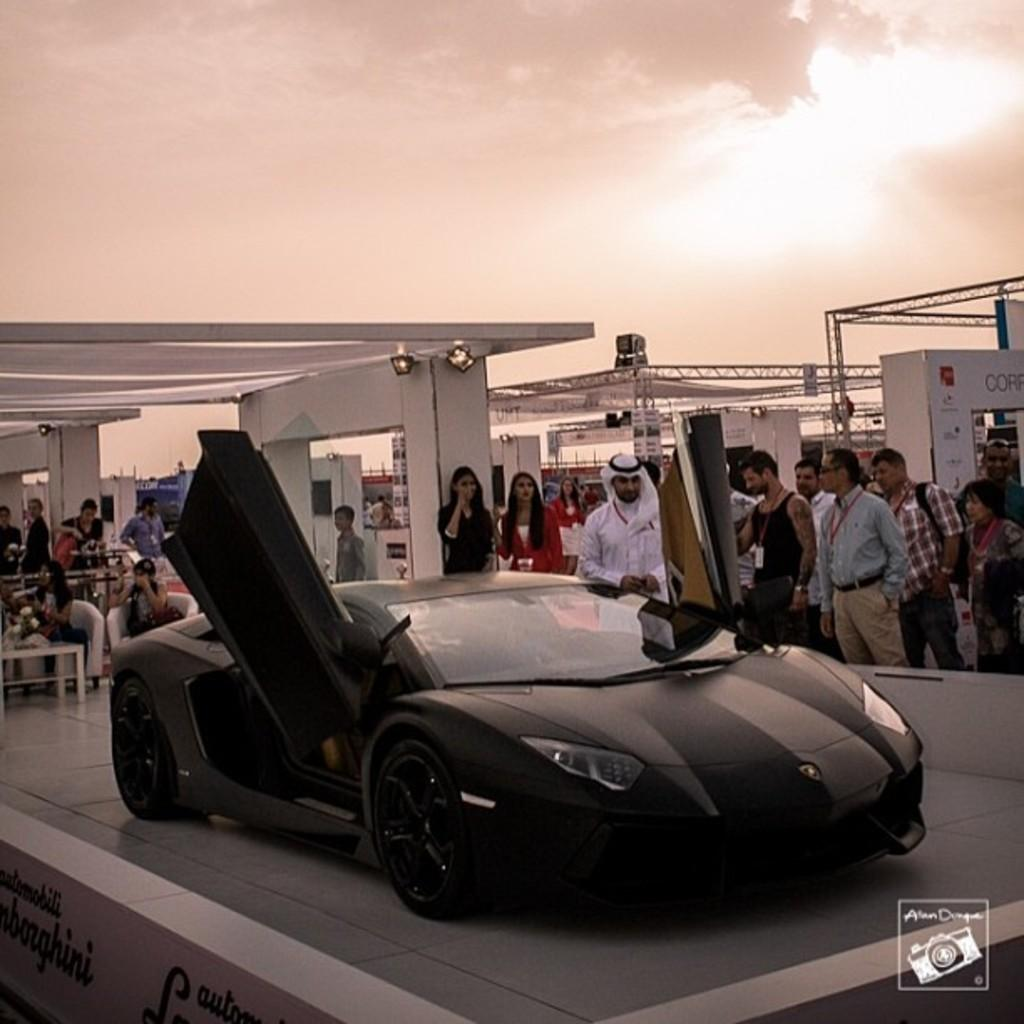What is the main subject of the image? The main subject of the image is a car. What are the people in the image wearing? The people in the image are wearing access cards. What can be seen in the background of the image? There are lights visible in the image. How many couches are in the image? There are 2 couches in the image. What is in front of the couches? There is a table in front of the couches. What is visible at the top of the image? The sky is visible in the image. Where is the basin located in the image? There is no basin present in the image. What type of discussion is taking place between the people in the image? There is no discussion taking place between the people in the image; they are simply wearing access cards. 